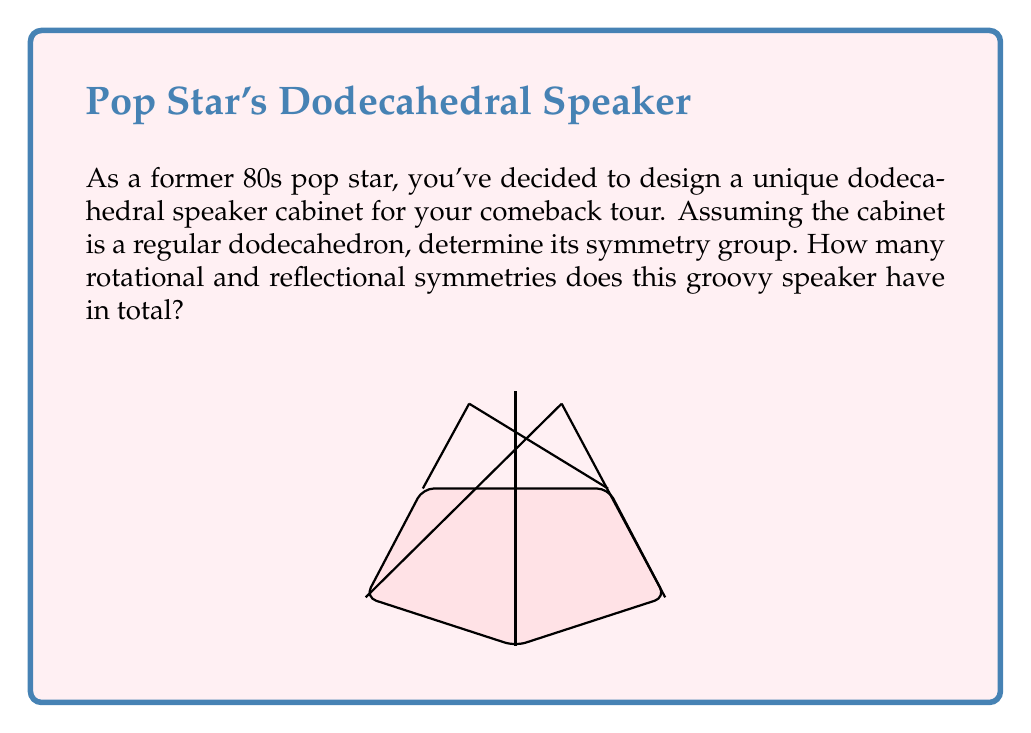Can you answer this question? Let's approach this step-by-step:

1) The symmetry group of a regular dodecahedron is known as the icosahedral group, often denoted as $I_h$.

2) To determine the total number of symmetries, we need to consider both rotational and reflectional symmetries:

   a) Rotational symmetries:
      - 15-fold rotations: There are 6 five-fold rotation axes through the centers of opposite faces.
      - 10-fold rotations: There are 10 three-fold rotation axes through opposite vertices.
      - 15-fold rotations: There are 15 two-fold rotation axes through the midpoints of opposite edges.

   The total number of rotational symmetries is: $1 + (6 \times 4) + (10 \times 2) + 15 = 60$

   b) Reflectional symmetries:
      The dodecahedron has 15 planes of symmetry: 
      - 6 through opposite edges
      - 9 through opposite vertices

3) The total number of symmetries is twice the number of rotational symmetries, as each rotation can be combined with the identity or an inversion.

4) Therefore, the order of the symmetry group is: $60 \times 2 = 120$

5) In group theory notation, this symmetry group can be written as:

   $$I_h \cong A_5 \times \mathbb{Z}_2$$

   Where $A_5$ is the alternating group on 5 elements (corresponding to the 60 rotational symmetries) and $\mathbb{Z}_2$ is the cyclic group of order 2 (corresponding to the presence or absence of inversion).
Answer: $I_h$, order 120 